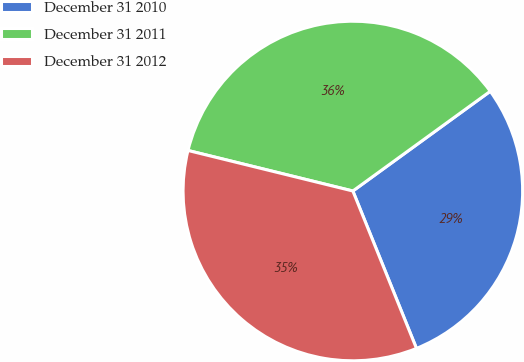Convert chart to OTSL. <chart><loc_0><loc_0><loc_500><loc_500><pie_chart><fcel>December 31 2010<fcel>December 31 2011<fcel>December 31 2012<nl><fcel>28.88%<fcel>36.17%<fcel>34.95%<nl></chart> 